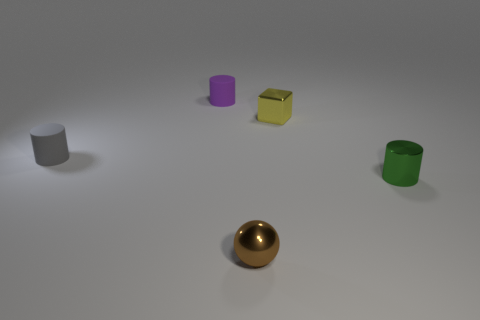Are there any red blocks?
Ensure brevity in your answer.  No. There is a brown sphere that is made of the same material as the yellow thing; what is its size?
Give a very brief answer. Small. Is there a metal ball that has the same color as the tiny metallic cylinder?
Keep it short and to the point. No. Is the color of the small rubber object that is behind the gray object the same as the tiny metallic thing that is behind the tiny green metallic cylinder?
Offer a very short reply. No. Is there a tiny cylinder that has the same material as the small brown ball?
Your answer should be very brief. Yes. The sphere has what color?
Your answer should be compact. Brown. There is a cylinder that is on the right side of the tiny object that is in front of the cylinder that is on the right side of the small shiny ball; what size is it?
Offer a very short reply. Small. What number of other things are there of the same shape as the tiny yellow metal object?
Your answer should be compact. 0. The cylinder that is both in front of the purple object and right of the tiny gray matte cylinder is what color?
Give a very brief answer. Green. Is the color of the cylinder that is to the right of the brown metallic ball the same as the metal block?
Your answer should be very brief. No. 